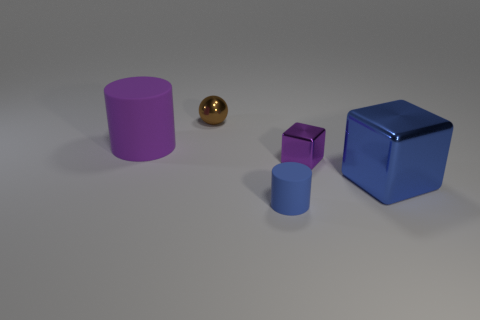Add 1 purple metal blocks. How many objects exist? 6 Subtract all spheres. How many objects are left? 4 Subtract 0 cyan cylinders. How many objects are left? 5 Subtract all yellow cubes. Subtract all purple cylinders. How many cubes are left? 2 Subtract all big purple things. Subtract all tiny green metallic spheres. How many objects are left? 4 Add 1 purple objects. How many purple objects are left? 3 Add 2 purple objects. How many purple objects exist? 4 